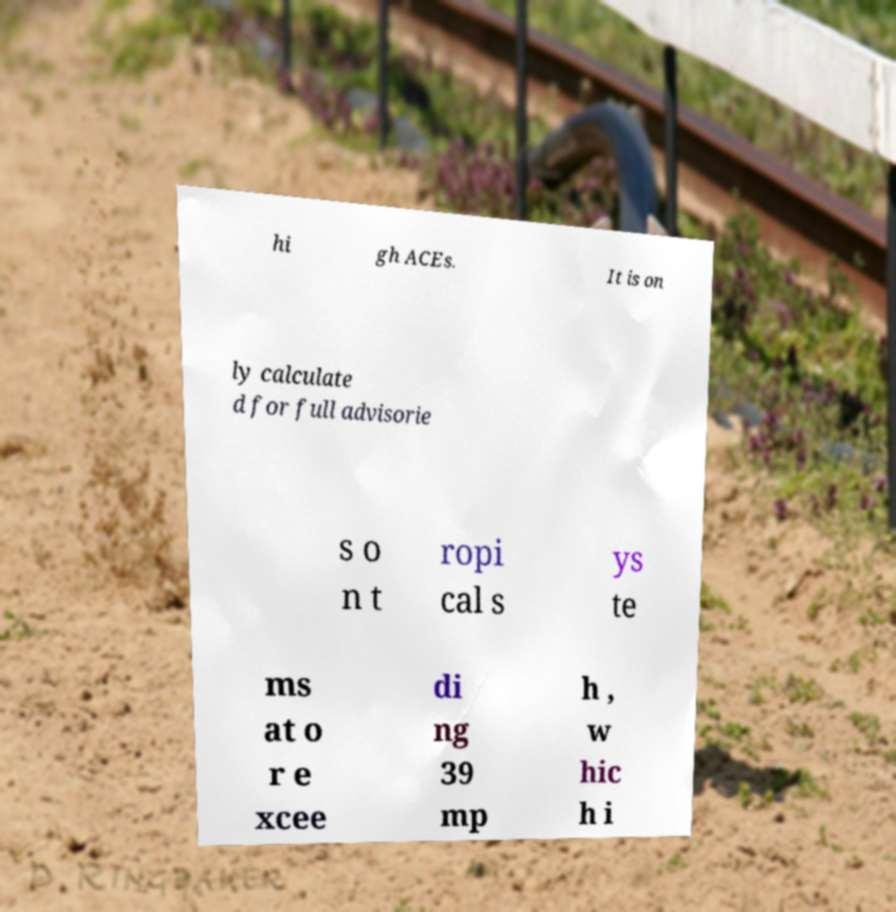Could you assist in decoding the text presented in this image and type it out clearly? hi gh ACEs. It is on ly calculate d for full advisorie s o n t ropi cal s ys te ms at o r e xcee di ng 39 mp h , w hic h i 